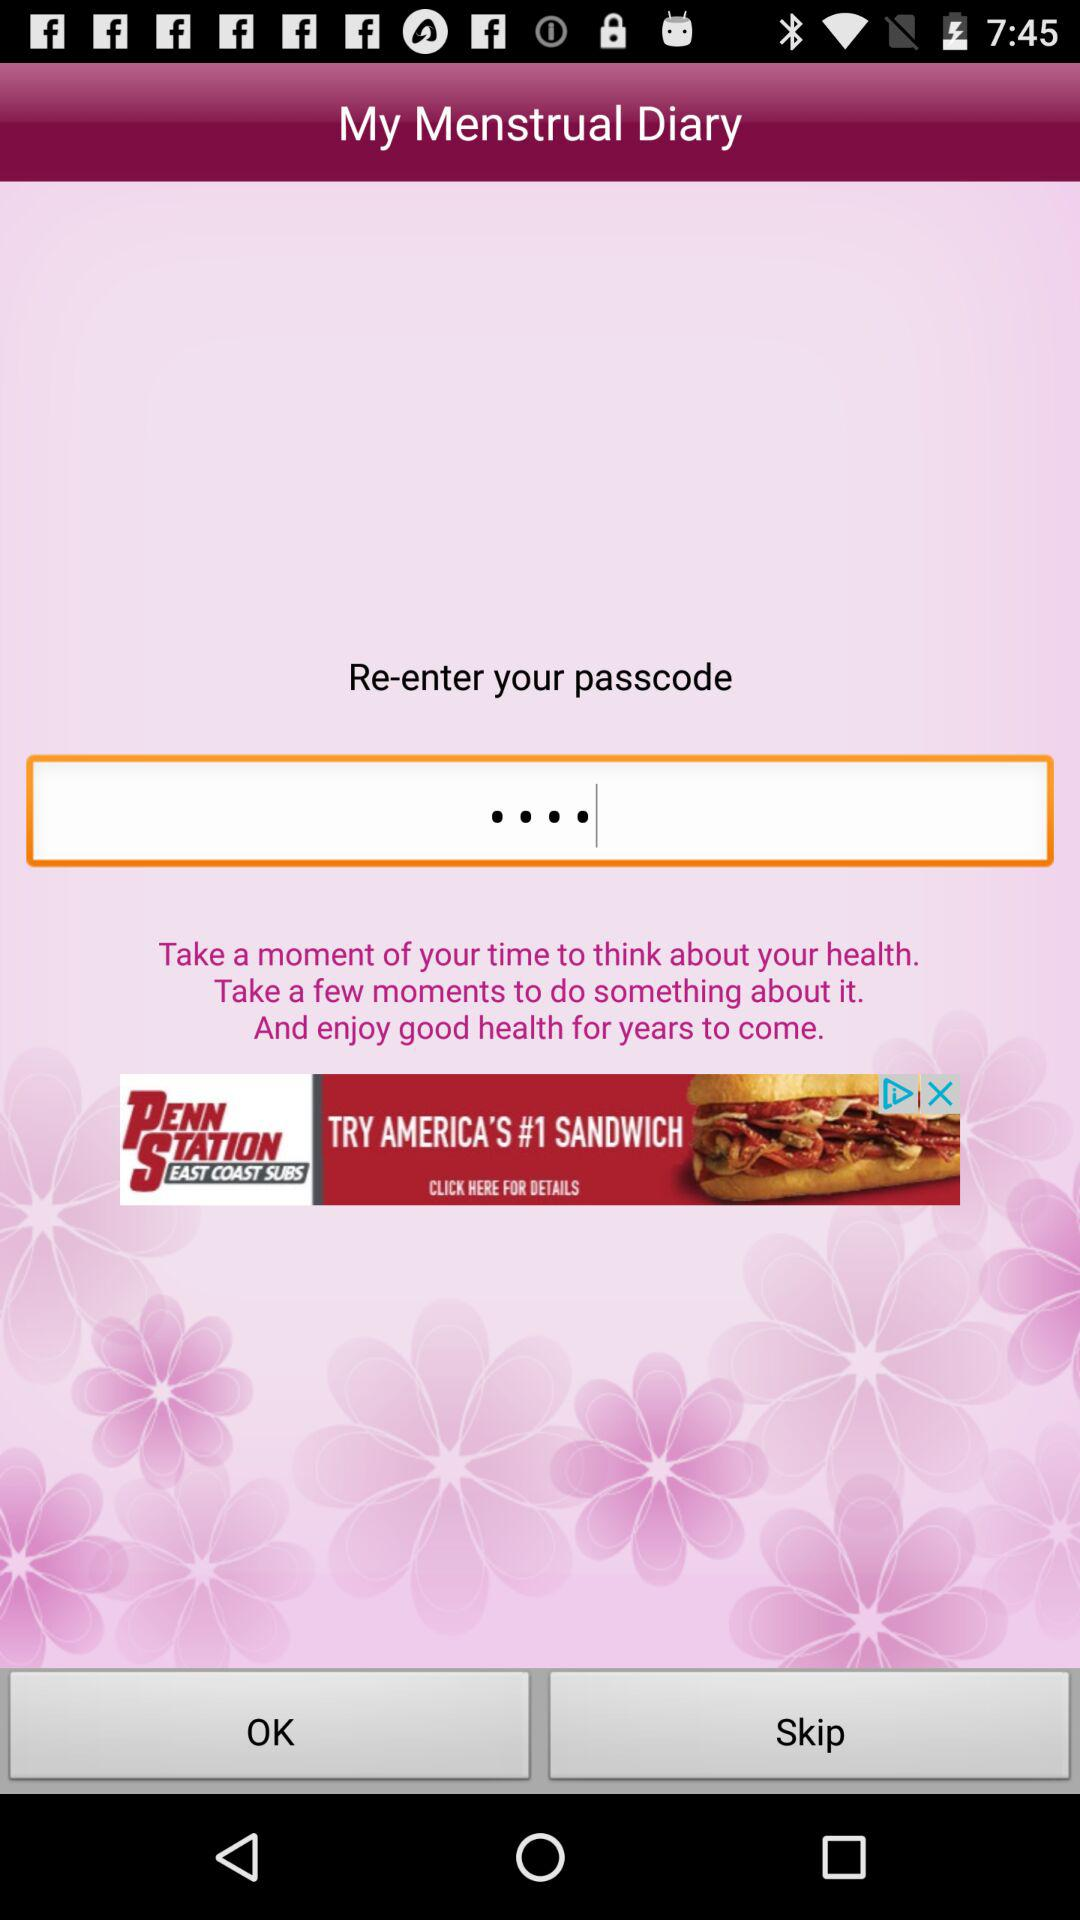What is the name of the application? The name of the application is "My Menstrual Diary". 